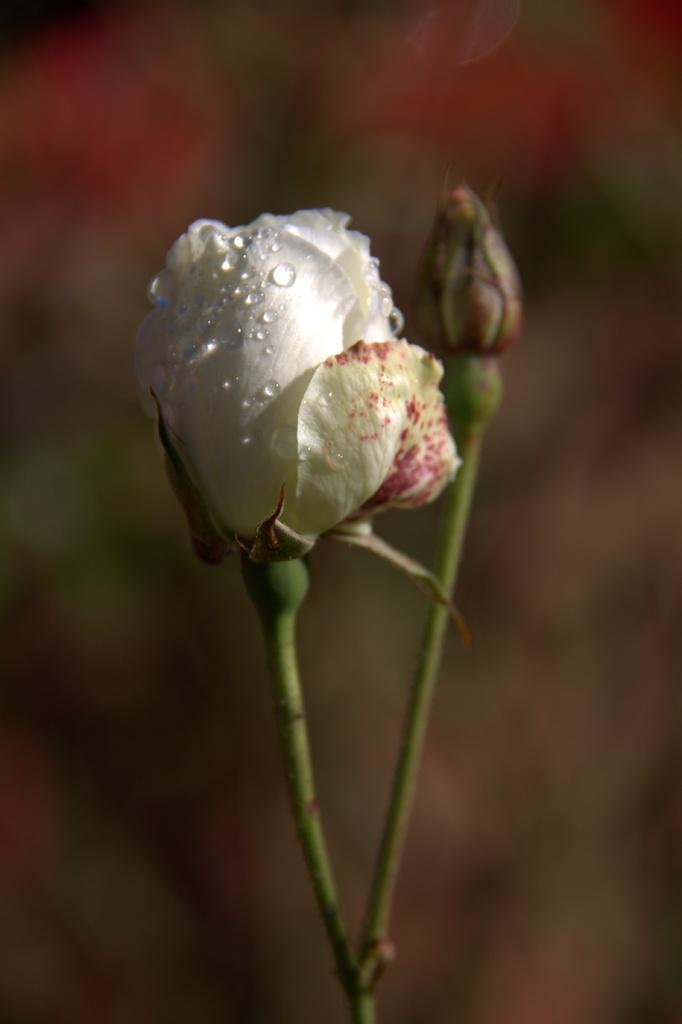Describe this image in one or two sentences. In this image in the foreground there is one flower, in the background there are some plants. 